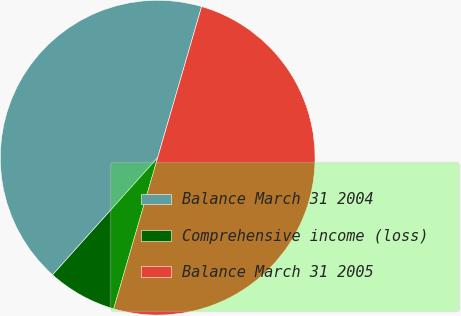<chart> <loc_0><loc_0><loc_500><loc_500><pie_chart><fcel>Balance March 31 2004<fcel>Comprehensive income (loss)<fcel>Balance March 31 2005<nl><fcel>42.87%<fcel>7.13%<fcel>50.0%<nl></chart> 